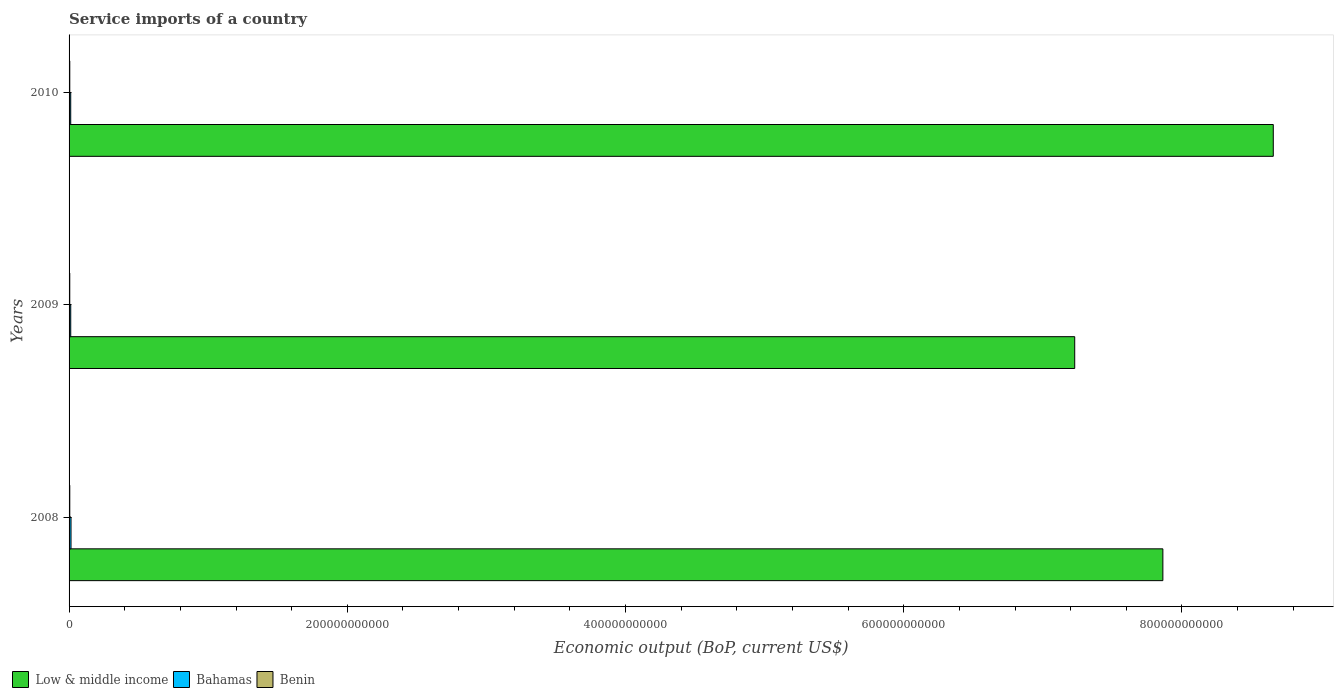How many groups of bars are there?
Your answer should be very brief. 3. Are the number of bars per tick equal to the number of legend labels?
Provide a succinct answer. Yes. Are the number of bars on each tick of the Y-axis equal?
Keep it short and to the point. Yes. What is the label of the 3rd group of bars from the top?
Offer a very short reply. 2008. What is the service imports in Bahamas in 2010?
Keep it short and to the point. 1.18e+09. Across all years, what is the maximum service imports in Benin?
Your response must be concise. 5.15e+08. Across all years, what is the minimum service imports in Benin?
Ensure brevity in your answer.  4.96e+08. In which year was the service imports in Benin maximum?
Make the answer very short. 2010. What is the total service imports in Bahamas in the graph?
Your response must be concise. 3.78e+09. What is the difference between the service imports in Low & middle income in 2008 and that in 2010?
Make the answer very short. -7.94e+1. What is the difference between the service imports in Low & middle income in 2010 and the service imports in Bahamas in 2009?
Your response must be concise. 8.64e+11. What is the average service imports in Benin per year?
Give a very brief answer. 5.07e+08. In the year 2009, what is the difference between the service imports in Bahamas and service imports in Low & middle income?
Ensure brevity in your answer.  -7.22e+11. In how many years, is the service imports in Bahamas greater than 120000000000 US$?
Provide a succinct answer. 0. What is the ratio of the service imports in Bahamas in 2008 to that in 2009?
Give a very brief answer. 1.17. Is the difference between the service imports in Bahamas in 2008 and 2009 greater than the difference between the service imports in Low & middle income in 2008 and 2009?
Offer a very short reply. No. What is the difference between the highest and the second highest service imports in Benin?
Make the answer very short. 4.67e+06. What is the difference between the highest and the lowest service imports in Bahamas?
Provide a short and direct response. 2.22e+08. In how many years, is the service imports in Bahamas greater than the average service imports in Bahamas taken over all years?
Keep it short and to the point. 1. What does the 1st bar from the top in 2009 represents?
Ensure brevity in your answer.  Benin. What does the 3rd bar from the bottom in 2009 represents?
Make the answer very short. Benin. Is it the case that in every year, the sum of the service imports in Low & middle income and service imports in Bahamas is greater than the service imports in Benin?
Provide a succinct answer. Yes. How many bars are there?
Make the answer very short. 9. Are all the bars in the graph horizontal?
Provide a succinct answer. Yes. What is the difference between two consecutive major ticks on the X-axis?
Your answer should be very brief. 2.00e+11. Does the graph contain any zero values?
Provide a short and direct response. No. What is the title of the graph?
Provide a short and direct response. Service imports of a country. What is the label or title of the X-axis?
Offer a terse response. Economic output (BoP, current US$). What is the Economic output (BoP, current US$) in Low & middle income in 2008?
Ensure brevity in your answer.  7.86e+11. What is the Economic output (BoP, current US$) in Bahamas in 2008?
Give a very brief answer. 1.40e+09. What is the Economic output (BoP, current US$) in Benin in 2008?
Keep it short and to the point. 5.10e+08. What is the Economic output (BoP, current US$) of Low & middle income in 2009?
Offer a very short reply. 7.23e+11. What is the Economic output (BoP, current US$) in Bahamas in 2009?
Ensure brevity in your answer.  1.20e+09. What is the Economic output (BoP, current US$) in Benin in 2009?
Give a very brief answer. 4.96e+08. What is the Economic output (BoP, current US$) of Low & middle income in 2010?
Provide a short and direct response. 8.66e+11. What is the Economic output (BoP, current US$) of Bahamas in 2010?
Offer a very short reply. 1.18e+09. What is the Economic output (BoP, current US$) in Benin in 2010?
Give a very brief answer. 5.15e+08. Across all years, what is the maximum Economic output (BoP, current US$) of Low & middle income?
Provide a succinct answer. 8.66e+11. Across all years, what is the maximum Economic output (BoP, current US$) of Bahamas?
Make the answer very short. 1.40e+09. Across all years, what is the maximum Economic output (BoP, current US$) of Benin?
Your answer should be very brief. 5.15e+08. Across all years, what is the minimum Economic output (BoP, current US$) in Low & middle income?
Your answer should be compact. 7.23e+11. Across all years, what is the minimum Economic output (BoP, current US$) in Bahamas?
Provide a short and direct response. 1.18e+09. Across all years, what is the minimum Economic output (BoP, current US$) of Benin?
Your answer should be very brief. 4.96e+08. What is the total Economic output (BoP, current US$) of Low & middle income in the graph?
Your response must be concise. 2.37e+12. What is the total Economic output (BoP, current US$) in Bahamas in the graph?
Give a very brief answer. 3.78e+09. What is the total Economic output (BoP, current US$) in Benin in the graph?
Ensure brevity in your answer.  1.52e+09. What is the difference between the Economic output (BoP, current US$) in Low & middle income in 2008 and that in 2009?
Provide a succinct answer. 6.34e+1. What is the difference between the Economic output (BoP, current US$) of Bahamas in 2008 and that in 2009?
Give a very brief answer. 2.07e+08. What is the difference between the Economic output (BoP, current US$) of Benin in 2008 and that in 2009?
Ensure brevity in your answer.  1.41e+07. What is the difference between the Economic output (BoP, current US$) of Low & middle income in 2008 and that in 2010?
Ensure brevity in your answer.  -7.94e+1. What is the difference between the Economic output (BoP, current US$) of Bahamas in 2008 and that in 2010?
Provide a short and direct response. 2.22e+08. What is the difference between the Economic output (BoP, current US$) of Benin in 2008 and that in 2010?
Provide a short and direct response. -4.67e+06. What is the difference between the Economic output (BoP, current US$) of Low & middle income in 2009 and that in 2010?
Offer a terse response. -1.43e+11. What is the difference between the Economic output (BoP, current US$) in Bahamas in 2009 and that in 2010?
Your response must be concise. 1.50e+07. What is the difference between the Economic output (BoP, current US$) in Benin in 2009 and that in 2010?
Provide a succinct answer. -1.88e+07. What is the difference between the Economic output (BoP, current US$) in Low & middle income in 2008 and the Economic output (BoP, current US$) in Bahamas in 2009?
Give a very brief answer. 7.85e+11. What is the difference between the Economic output (BoP, current US$) in Low & middle income in 2008 and the Economic output (BoP, current US$) in Benin in 2009?
Provide a succinct answer. 7.86e+11. What is the difference between the Economic output (BoP, current US$) in Bahamas in 2008 and the Economic output (BoP, current US$) in Benin in 2009?
Ensure brevity in your answer.  9.07e+08. What is the difference between the Economic output (BoP, current US$) of Low & middle income in 2008 and the Economic output (BoP, current US$) of Bahamas in 2010?
Your answer should be compact. 7.85e+11. What is the difference between the Economic output (BoP, current US$) in Low & middle income in 2008 and the Economic output (BoP, current US$) in Benin in 2010?
Give a very brief answer. 7.86e+11. What is the difference between the Economic output (BoP, current US$) of Bahamas in 2008 and the Economic output (BoP, current US$) of Benin in 2010?
Offer a very short reply. 8.88e+08. What is the difference between the Economic output (BoP, current US$) of Low & middle income in 2009 and the Economic output (BoP, current US$) of Bahamas in 2010?
Keep it short and to the point. 7.22e+11. What is the difference between the Economic output (BoP, current US$) in Low & middle income in 2009 and the Economic output (BoP, current US$) in Benin in 2010?
Make the answer very short. 7.22e+11. What is the difference between the Economic output (BoP, current US$) of Bahamas in 2009 and the Economic output (BoP, current US$) of Benin in 2010?
Your answer should be very brief. 6.81e+08. What is the average Economic output (BoP, current US$) in Low & middle income per year?
Make the answer very short. 7.92e+11. What is the average Economic output (BoP, current US$) in Bahamas per year?
Provide a succinct answer. 1.26e+09. What is the average Economic output (BoP, current US$) of Benin per year?
Make the answer very short. 5.07e+08. In the year 2008, what is the difference between the Economic output (BoP, current US$) of Low & middle income and Economic output (BoP, current US$) of Bahamas?
Offer a terse response. 7.85e+11. In the year 2008, what is the difference between the Economic output (BoP, current US$) of Low & middle income and Economic output (BoP, current US$) of Benin?
Your answer should be compact. 7.86e+11. In the year 2008, what is the difference between the Economic output (BoP, current US$) of Bahamas and Economic output (BoP, current US$) of Benin?
Provide a succinct answer. 8.93e+08. In the year 2009, what is the difference between the Economic output (BoP, current US$) of Low & middle income and Economic output (BoP, current US$) of Bahamas?
Provide a succinct answer. 7.22e+11. In the year 2009, what is the difference between the Economic output (BoP, current US$) of Low & middle income and Economic output (BoP, current US$) of Benin?
Offer a very short reply. 7.22e+11. In the year 2009, what is the difference between the Economic output (BoP, current US$) of Bahamas and Economic output (BoP, current US$) of Benin?
Keep it short and to the point. 7.00e+08. In the year 2010, what is the difference between the Economic output (BoP, current US$) of Low & middle income and Economic output (BoP, current US$) of Bahamas?
Your answer should be compact. 8.64e+11. In the year 2010, what is the difference between the Economic output (BoP, current US$) in Low & middle income and Economic output (BoP, current US$) in Benin?
Keep it short and to the point. 8.65e+11. In the year 2010, what is the difference between the Economic output (BoP, current US$) of Bahamas and Economic output (BoP, current US$) of Benin?
Keep it short and to the point. 6.66e+08. What is the ratio of the Economic output (BoP, current US$) in Low & middle income in 2008 to that in 2009?
Ensure brevity in your answer.  1.09. What is the ratio of the Economic output (BoP, current US$) of Bahamas in 2008 to that in 2009?
Give a very brief answer. 1.17. What is the ratio of the Economic output (BoP, current US$) in Benin in 2008 to that in 2009?
Make the answer very short. 1.03. What is the ratio of the Economic output (BoP, current US$) in Low & middle income in 2008 to that in 2010?
Keep it short and to the point. 0.91. What is the ratio of the Economic output (BoP, current US$) of Bahamas in 2008 to that in 2010?
Your answer should be compact. 1.19. What is the ratio of the Economic output (BoP, current US$) of Benin in 2008 to that in 2010?
Offer a terse response. 0.99. What is the ratio of the Economic output (BoP, current US$) in Low & middle income in 2009 to that in 2010?
Give a very brief answer. 0.84. What is the ratio of the Economic output (BoP, current US$) in Bahamas in 2009 to that in 2010?
Provide a succinct answer. 1.01. What is the ratio of the Economic output (BoP, current US$) in Benin in 2009 to that in 2010?
Provide a succinct answer. 0.96. What is the difference between the highest and the second highest Economic output (BoP, current US$) in Low & middle income?
Keep it short and to the point. 7.94e+1. What is the difference between the highest and the second highest Economic output (BoP, current US$) in Bahamas?
Your answer should be very brief. 2.07e+08. What is the difference between the highest and the second highest Economic output (BoP, current US$) of Benin?
Offer a terse response. 4.67e+06. What is the difference between the highest and the lowest Economic output (BoP, current US$) of Low & middle income?
Offer a very short reply. 1.43e+11. What is the difference between the highest and the lowest Economic output (BoP, current US$) in Bahamas?
Provide a succinct answer. 2.22e+08. What is the difference between the highest and the lowest Economic output (BoP, current US$) in Benin?
Ensure brevity in your answer.  1.88e+07. 